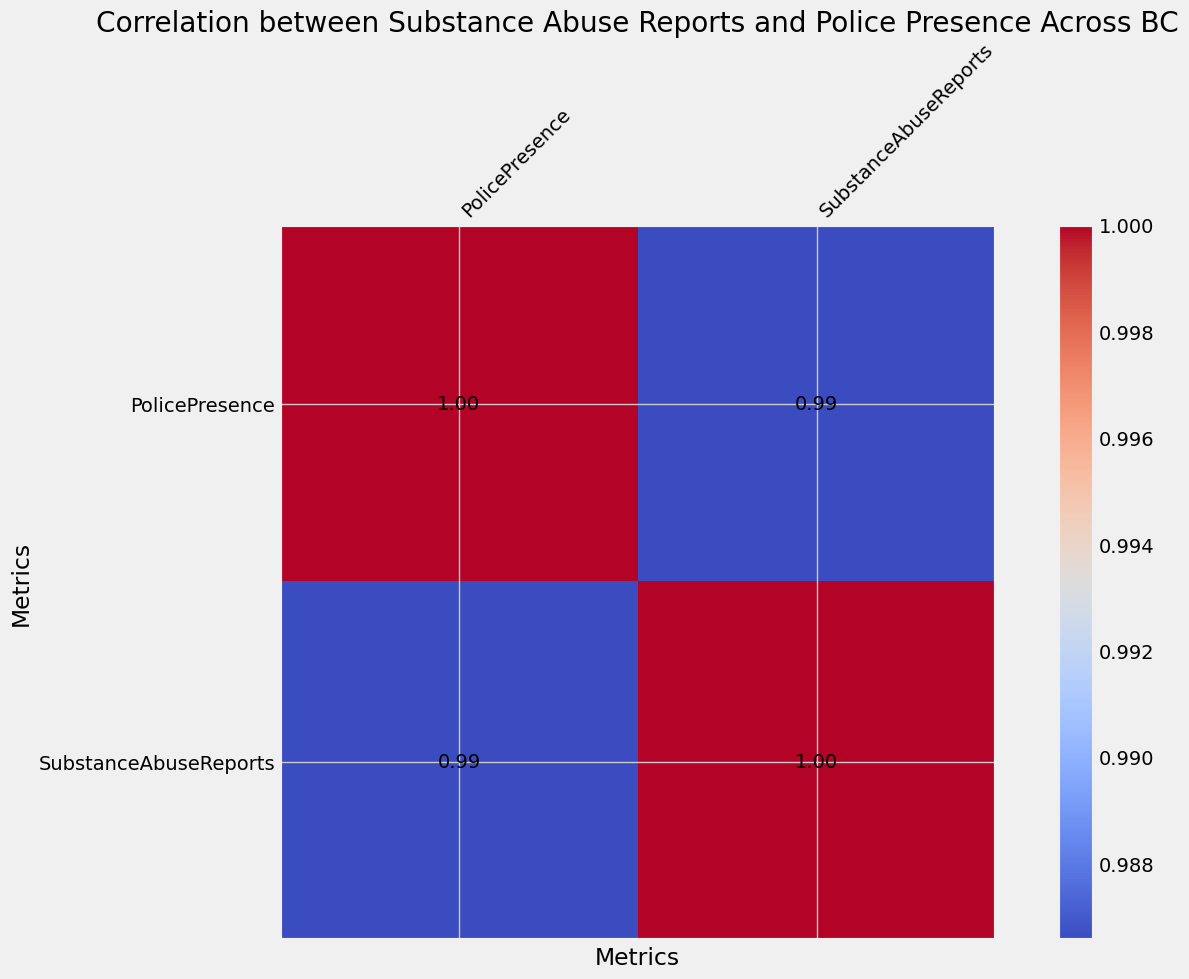What is the correlation coefficient between Substance Abuse Reports and Police Presence? Look at the value in the heatmap at the intersection of "SubstanceAbuseReports" and "PolicePresence". The number shows how the two metrics are correlated.
Answer: 1.00 Is the correlation between Substance Abuse Reports and Police Presence positive or negative? The number at the intersection of "SubstanceAbuseReports" and "PolicePresence" is 1.00. Correlation values range from -1 to 1, where positive values indicate a positive correlation, and negative values indicate a negative correlation.
Answer: Positive How does the correlation between Substance Abuse Reports and Police Presence compare to a perfect correlation? A perfect correlation is represented by a correlation coefficient of 1 or -1. The heat map shows a correlation of 1.00 between Substance Abuse Reports and Police Presence, which indicates a perfect positive correlation.
Answer: Perfect positive correlation Which metric has the highest correlation with itself, Substance Abuse Reports or Police Presence? Both metrics will have a correlation of 1.00 with themselves as indicated by the diagonal values on the heatmap.
Answer: Both What is the significance of the color at the intersection of Substance Abuse Reports and Police Presence? The color in the heatmap for the intersection between "SubstanceAbuseReports" and "PolicePresence" appears in the deepest shade, indicating the maximum correlation value on the color scale.
Answer: Maximum correlation What is the primary insight we can obtain from the heatmap regarding the relationship between Police Presence and Substance Abuse Reports? The heatmap shows a correlation coefficient of 1.00 between Police Presence and Substance Abuse Reports, indicating that higher police presence is perfectly correlated with the number of substance abuse reports in BC regions.
Answer: Perfect correlation If an additional metric had been added and showed a correlation of 0.5 with Substance Abuse Reports, what would this tell us about its relationship with Substance Abuse Reports compared to Police Presence? A correlation of 0.5 indicates a moderate positive correlation, which is weaker than the perfect positive correlation of 1.00 observed between Substance Abuse Reports and Police Presence.
Answer: Moderate positive correlation Can we infer causation from the correlation value given in the heatmap between Substance Abuse Reports and Police Presence? Correlation does not imply causation. The heatmap shows a strong correlation but does not indicate that one metric causes the changes in the other.
Answer: No Would it be appropriate to prioritize increasing Police Presence in regions with high Substance Abuse Reports based on this heatmap information alone? The heatmap shows a correlation but does not provide enough information on causation or additional factors that may influence Substance Abuse Reports. Further analysis would be needed to make such a decision.
Answer: No What is the main visual difference you observe when comparing the values on the diagonal of the heatmap with the off-diagonal values? The diagonal values are all 1.00, indicating perfect self-correlation, while the off-diagonal value between "SubstanceAbuseReports" and "PolicePresence" is also 1.00, indicating a perfect positive correlation between the two metrics.
Answer: Diagonal values are 1.00, off-diagonal 1.00 